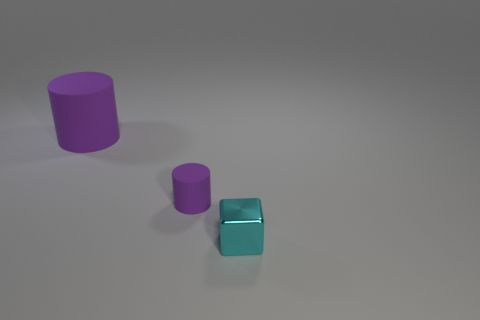There is a tiny rubber object that is the same shape as the large purple rubber thing; what color is it?
Offer a terse response. Purple. There is another cylinder that is the same color as the large matte cylinder; what material is it?
Your answer should be compact. Rubber. What number of other cyan metallic objects are the same shape as the tiny cyan thing?
Your answer should be very brief. 0. Do the small rubber object and the tiny metallic cube have the same color?
Ensure brevity in your answer.  No. Is the number of small cyan cubes less than the number of tiny blue shiny blocks?
Make the answer very short. No. There is a purple cylinder to the left of the tiny purple rubber thing; what material is it?
Make the answer very short. Rubber. What is the material of the other thing that is the same size as the cyan object?
Provide a succinct answer. Rubber. There is a small object that is left of the small object that is in front of the small object that is to the left of the cyan shiny block; what is it made of?
Keep it short and to the point. Rubber. Is the number of blue rubber spheres greater than the number of cyan shiny things?
Give a very brief answer. No. How many small objects are cyan cubes or red cubes?
Keep it short and to the point. 1. 